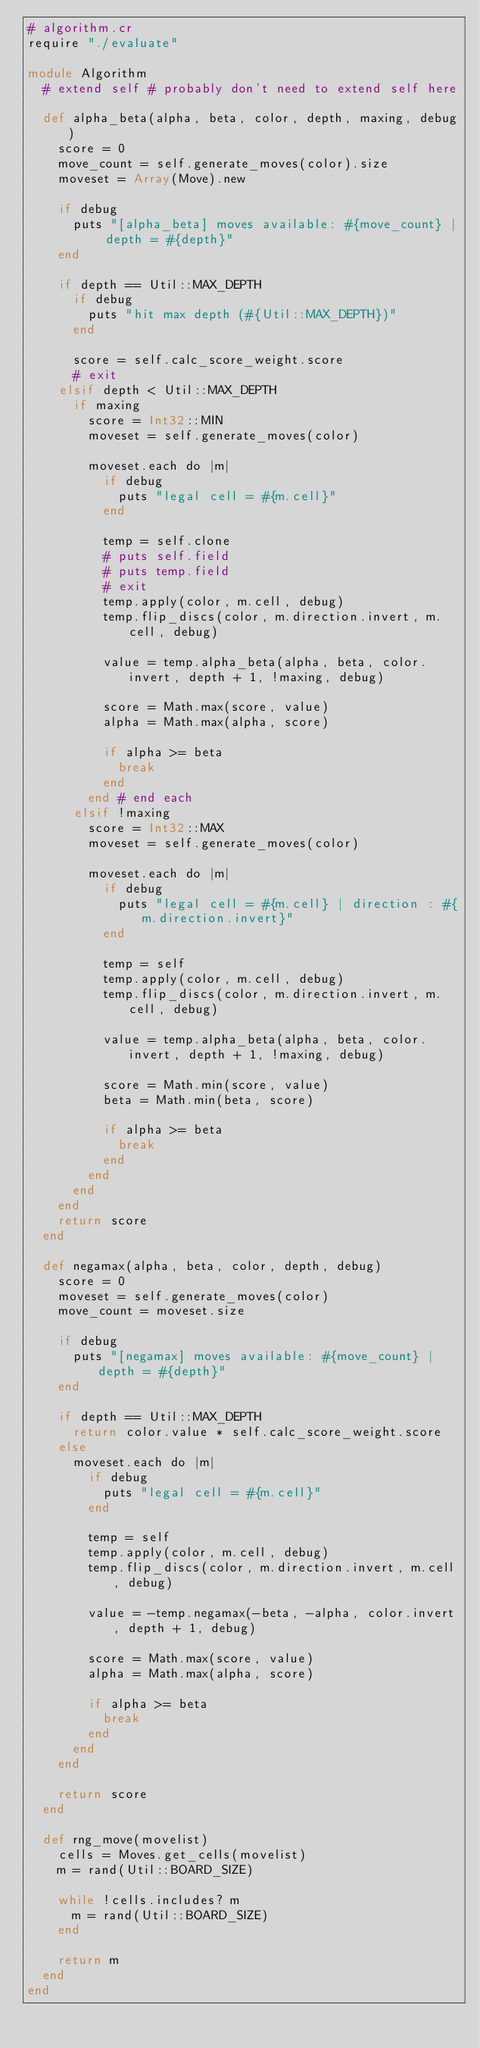<code> <loc_0><loc_0><loc_500><loc_500><_Crystal_># algorithm.cr
require "./evaluate"

module Algorithm
  # extend self # probably don't need to extend self here

  def alpha_beta(alpha, beta, color, depth, maxing, debug)
    score = 0
    move_count = self.generate_moves(color).size
    moveset = Array(Move).new

    if debug
      puts "[alpha_beta] moves available: #{move_count} | depth = #{depth}"
    end

    if depth == Util::MAX_DEPTH
      if debug
        puts "hit max depth (#{Util::MAX_DEPTH})"
      end

      score = self.calc_score_weight.score
      # exit
    elsif depth < Util::MAX_DEPTH
      if maxing
        score = Int32::MIN
        moveset = self.generate_moves(color)

        moveset.each do |m|
          if debug
            puts "legal cell = #{m.cell}"
          end

          temp = self.clone
          # puts self.field
          # puts temp.field
          # exit
          temp.apply(color, m.cell, debug)
          temp.flip_discs(color, m.direction.invert, m.cell, debug)

          value = temp.alpha_beta(alpha, beta, color.invert, depth + 1, !maxing, debug)

          score = Math.max(score, value)
          alpha = Math.max(alpha, score)

          if alpha >= beta
            break
          end
        end # end each
      elsif !maxing
        score = Int32::MAX
        moveset = self.generate_moves(color)

        moveset.each do |m|
          if debug
            puts "legal cell = #{m.cell} | direction : #{m.direction.invert}"
          end

          temp = self
          temp.apply(color, m.cell, debug)
          temp.flip_discs(color, m.direction.invert, m.cell, debug)

          value = temp.alpha_beta(alpha, beta, color.invert, depth + 1, !maxing, debug)

          score = Math.min(score, value)
          beta = Math.min(beta, score)

          if alpha >= beta
            break
          end
        end
      end
    end
    return score
  end

  def negamax(alpha, beta, color, depth, debug)
    score = 0
    moveset = self.generate_moves(color)
    move_count = moveset.size

    if debug
      puts "[negamax] moves available: #{move_count} | depth = #{depth}"
    end

    if depth == Util::MAX_DEPTH
      return color.value * self.calc_score_weight.score
    else
      moveset.each do |m|
        if debug
          puts "legal cell = #{m.cell}"
        end

        temp = self
        temp.apply(color, m.cell, debug)
        temp.flip_discs(color, m.direction.invert, m.cell, debug)

        value = -temp.negamax(-beta, -alpha, color.invert, depth + 1, debug)

        score = Math.max(score, value)
        alpha = Math.max(alpha, score)

        if alpha >= beta
          break
        end
      end
    end

    return score
  end

  def rng_move(movelist)
    cells = Moves.get_cells(movelist)
    m = rand(Util::BOARD_SIZE)

    while !cells.includes? m
      m = rand(Util::BOARD_SIZE)
    end

    return m
  end
end
</code> 